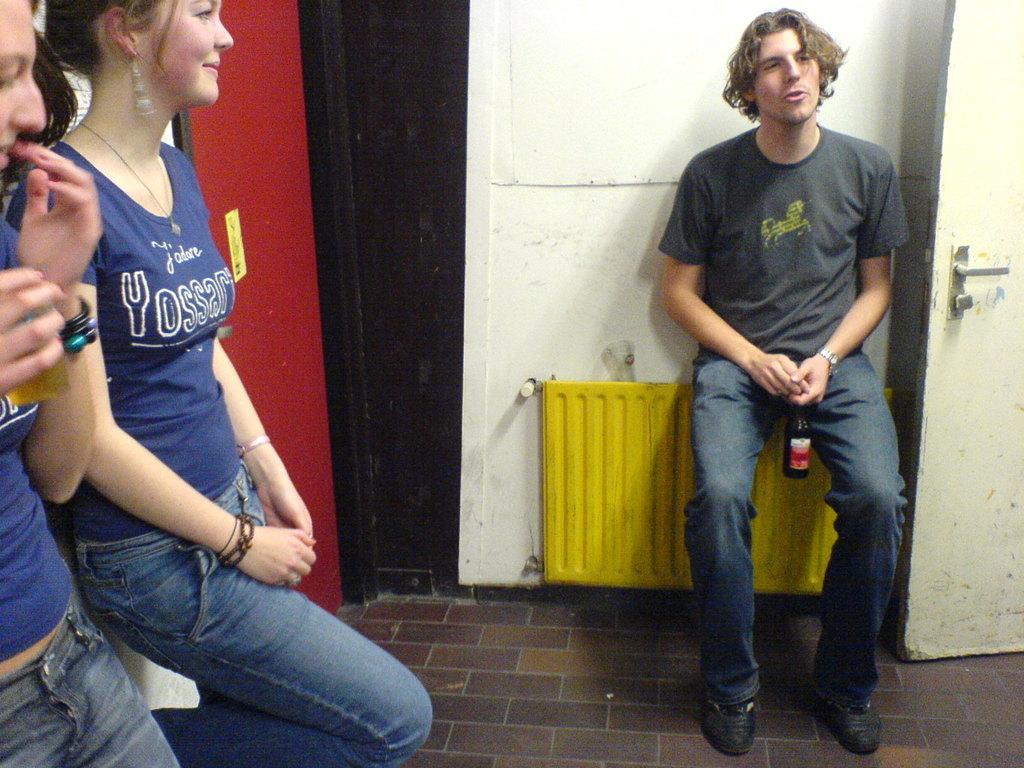Please provide a concise description of this image. In this image I can see two women wearing blue t shirt and blue jeans are standing and a man wearing black t shirt, blue jeans and black shoe is sitting and holding a bottle in his hand. In the background I can see the white colored wall, a yellow colored object and few surfaces which are black and red in color and to the right side of the image I can see the door. 